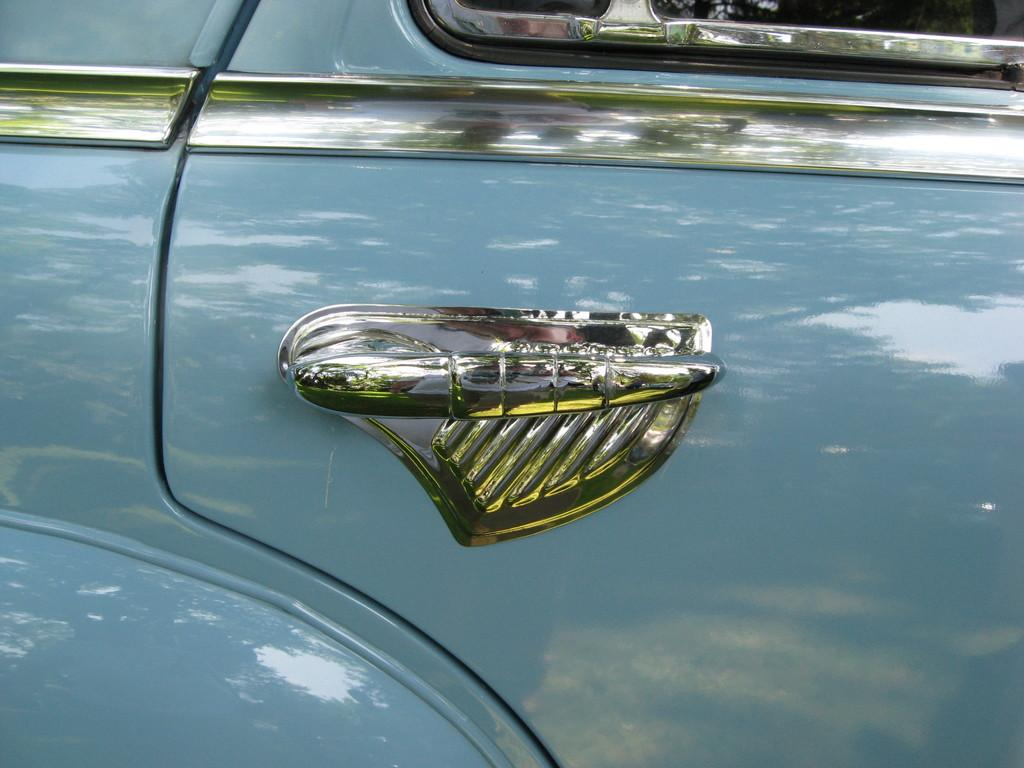What part of a car can be seen in the image? There is a car door in the image. What feature is present on the car door for opening and closing it? There is a handle for the car door in the image. How many times has your grandmother visited the mine in the image? There is no mine or grandmother present in the image; it only features a car door and its handle. 